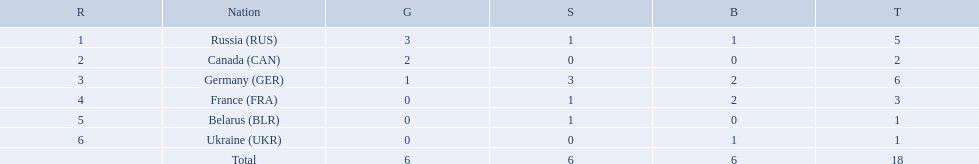Which countries had one or more gold medals? Russia (RUS), Canada (CAN), Germany (GER). Of these countries, which had at least one silver medal? Russia (RUS), Germany (GER). Of the remaining countries, who had more medals overall? Germany (GER). 